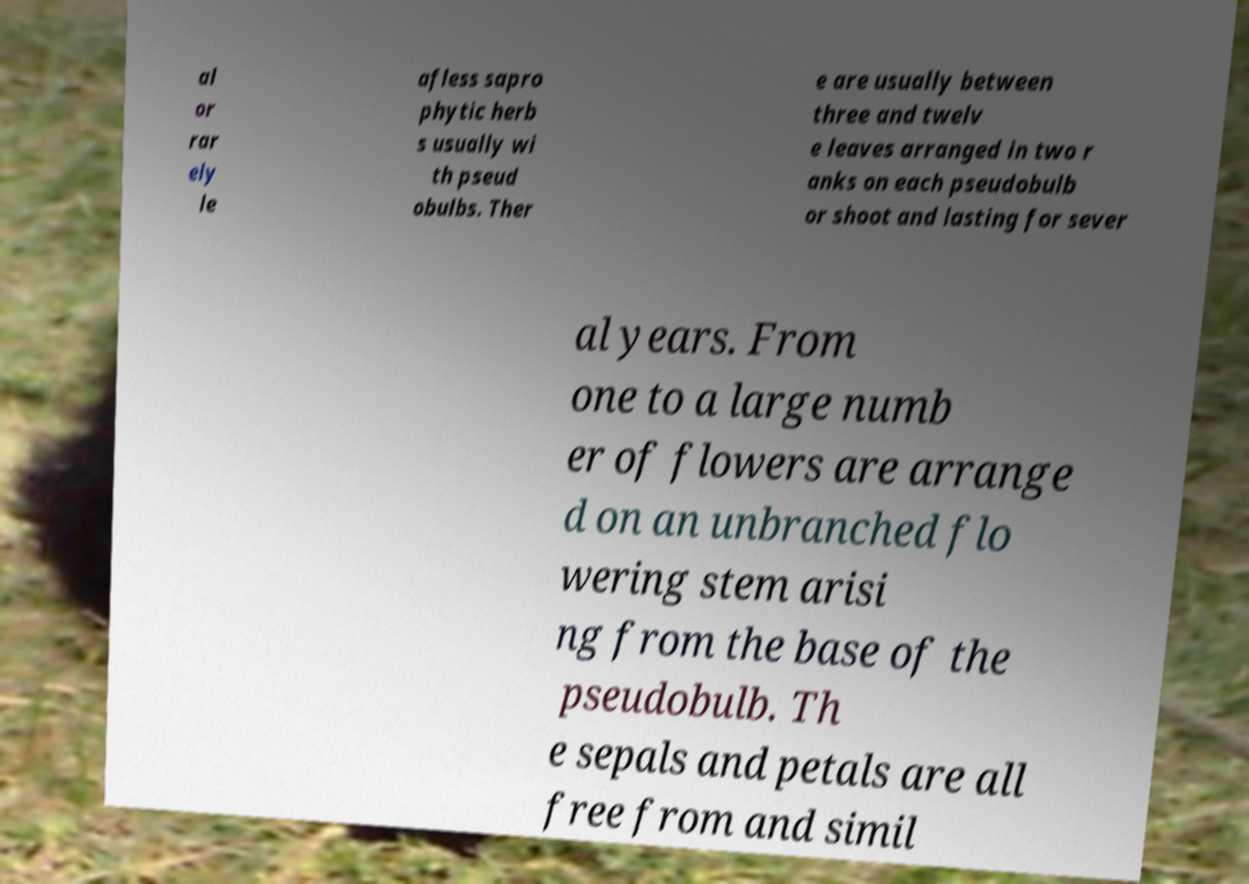Could you extract and type out the text from this image? al or rar ely le afless sapro phytic herb s usually wi th pseud obulbs. Ther e are usually between three and twelv e leaves arranged in two r anks on each pseudobulb or shoot and lasting for sever al years. From one to a large numb er of flowers are arrange d on an unbranched flo wering stem arisi ng from the base of the pseudobulb. Th e sepals and petals are all free from and simil 